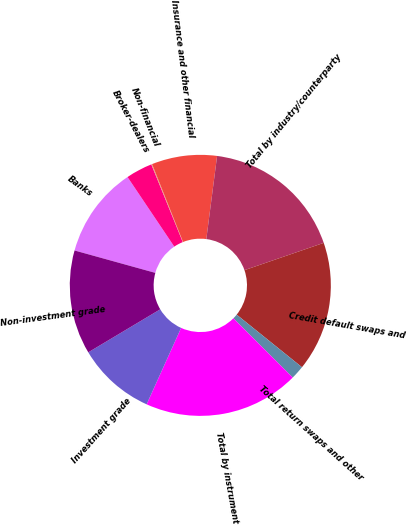<chart> <loc_0><loc_0><loc_500><loc_500><pie_chart><fcel>Banks<fcel>Broker-dealers<fcel>Non-financial<fcel>Insurance and other financial<fcel>Total by industry/counterparty<fcel>Credit default swaps and<fcel>Total return swaps and other<fcel>Total by instrument<fcel>Investment grade<fcel>Non-investment grade<nl><fcel>11.28%<fcel>3.29%<fcel>0.1%<fcel>8.08%<fcel>17.67%<fcel>16.07%<fcel>1.69%<fcel>19.27%<fcel>9.68%<fcel>12.88%<nl></chart> 